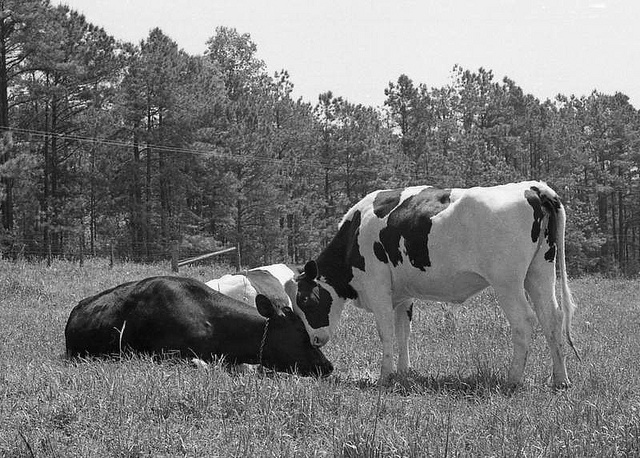Describe the objects in this image and their specific colors. I can see cow in gray, black, and lightgray tones, cow in gray, black, darkgray, and lightgray tones, and cow in gray, lightgray, darkgray, dimgray, and black tones in this image. 